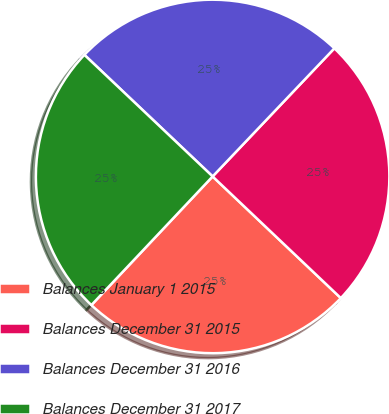<chart> <loc_0><loc_0><loc_500><loc_500><pie_chart><fcel>Balances January 1 2015<fcel>Balances December 31 2015<fcel>Balances December 31 2016<fcel>Balances December 31 2017<nl><fcel>24.95%<fcel>24.99%<fcel>25.02%<fcel>25.05%<nl></chart> 